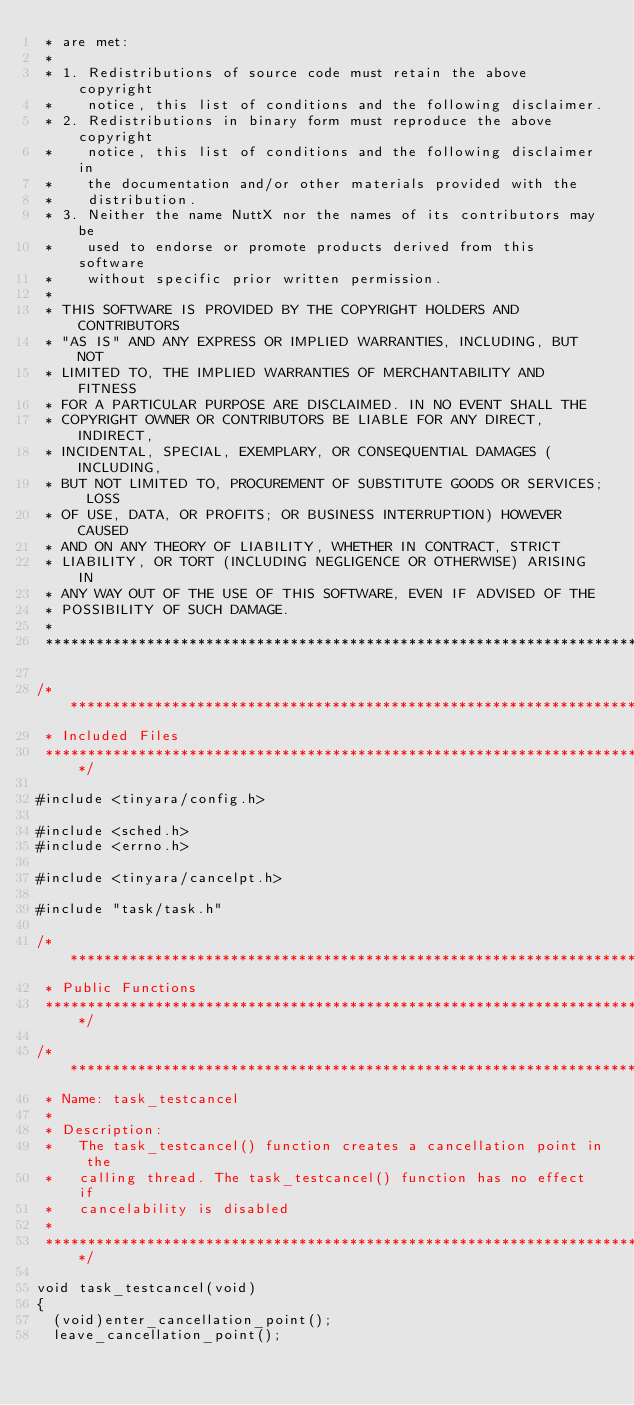<code> <loc_0><loc_0><loc_500><loc_500><_C_> * are met:
 *
 * 1. Redistributions of source code must retain the above copyright
 *    notice, this list of conditions and the following disclaimer.
 * 2. Redistributions in binary form must reproduce the above copyright
 *    notice, this list of conditions and the following disclaimer in
 *    the documentation and/or other materials provided with the
 *    distribution.
 * 3. Neither the name NuttX nor the names of its contributors may be
 *    used to endorse or promote products derived from this software
 *    without specific prior written permission.
 *
 * THIS SOFTWARE IS PROVIDED BY THE COPYRIGHT HOLDERS AND CONTRIBUTORS
 * "AS IS" AND ANY EXPRESS OR IMPLIED WARRANTIES, INCLUDING, BUT NOT
 * LIMITED TO, THE IMPLIED WARRANTIES OF MERCHANTABILITY AND FITNESS
 * FOR A PARTICULAR PURPOSE ARE DISCLAIMED. IN NO EVENT SHALL THE
 * COPYRIGHT OWNER OR CONTRIBUTORS BE LIABLE FOR ANY DIRECT, INDIRECT,
 * INCIDENTAL, SPECIAL, EXEMPLARY, OR CONSEQUENTIAL DAMAGES (INCLUDING,
 * BUT NOT LIMITED TO, PROCUREMENT OF SUBSTITUTE GOODS OR SERVICES; LOSS
 * OF USE, DATA, OR PROFITS; OR BUSINESS INTERRUPTION) HOWEVER CAUSED
 * AND ON ANY THEORY OF LIABILITY, WHETHER IN CONTRACT, STRICT
 * LIABILITY, OR TORT (INCLUDING NEGLIGENCE OR OTHERWISE) ARISING IN
 * ANY WAY OUT OF THE USE OF THIS SOFTWARE, EVEN IF ADVISED OF THE
 * POSSIBILITY OF SUCH DAMAGE.
 *
 ****************************************************************************/

/****************************************************************************
 * Included Files
 ****************************************************************************/

#include <tinyara/config.h>

#include <sched.h>
#include <errno.h>

#include <tinyara/cancelpt.h>

#include "task/task.h"

/****************************************************************************
 * Public Functions
 ****************************************************************************/

/****************************************************************************
 * Name: task_testcancel
 *
 * Description:
 *   The task_testcancel() function creates a cancellation point in the
 *   calling thread. The task_testcancel() function has no effect if
 *   cancelability is disabled
 *
 ****************************************************************************/

void task_testcancel(void)
{
	(void)enter_cancellation_point();
	leave_cancellation_point();</code> 